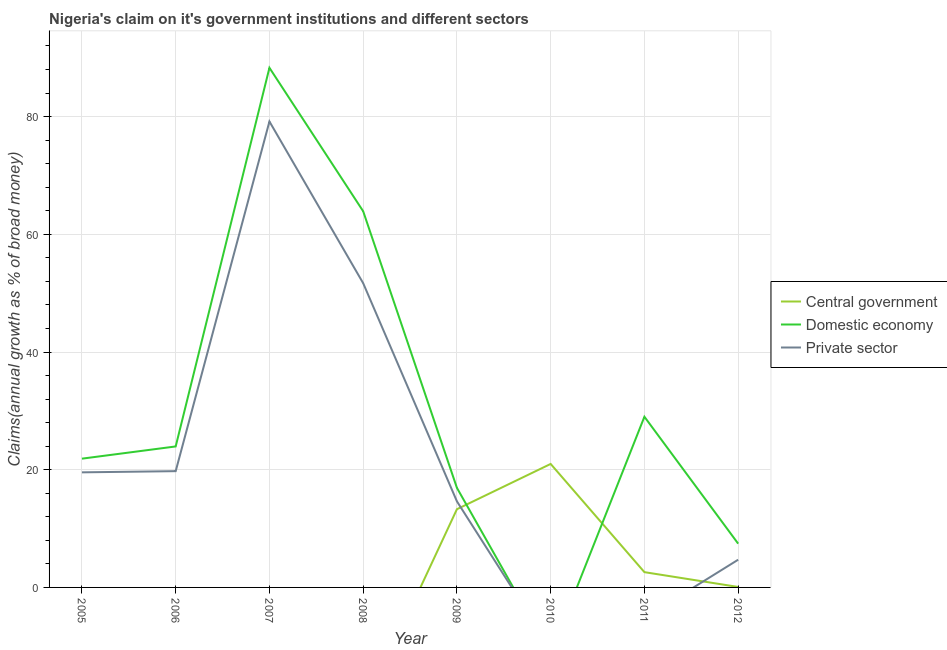Is the number of lines equal to the number of legend labels?
Your answer should be compact. No. What is the percentage of claim on the domestic economy in 2010?
Offer a terse response. 0. Across all years, what is the maximum percentage of claim on the central government?
Provide a short and direct response. 20.98. Across all years, what is the minimum percentage of claim on the central government?
Provide a succinct answer. 0. What is the total percentage of claim on the central government in the graph?
Offer a very short reply. 36.95. What is the difference between the percentage of claim on the private sector in 2006 and that in 2012?
Keep it short and to the point. 15.05. What is the difference between the percentage of claim on the domestic economy in 2005 and the percentage of claim on the central government in 2009?
Your response must be concise. 8.59. What is the average percentage of claim on the private sector per year?
Your answer should be compact. 23.69. In the year 2012, what is the difference between the percentage of claim on the private sector and percentage of claim on the domestic economy?
Provide a short and direct response. -2.73. In how many years, is the percentage of claim on the domestic economy greater than 72 %?
Provide a short and direct response. 1. What is the ratio of the percentage of claim on the domestic economy in 2005 to that in 2011?
Ensure brevity in your answer.  0.75. Is the difference between the percentage of claim on the private sector in 2005 and 2012 greater than the difference between the percentage of claim on the domestic economy in 2005 and 2012?
Keep it short and to the point. Yes. What is the difference between the highest and the second highest percentage of claim on the private sector?
Make the answer very short. 27.48. What is the difference between the highest and the lowest percentage of claim on the private sector?
Keep it short and to the point. 79.17. Is it the case that in every year, the sum of the percentage of claim on the central government and percentage of claim on the domestic economy is greater than the percentage of claim on the private sector?
Provide a succinct answer. Yes. What is the difference between two consecutive major ticks on the Y-axis?
Offer a terse response. 20. Are the values on the major ticks of Y-axis written in scientific E-notation?
Keep it short and to the point. No. Does the graph contain any zero values?
Ensure brevity in your answer.  Yes. Does the graph contain grids?
Keep it short and to the point. Yes. How many legend labels are there?
Provide a short and direct response. 3. What is the title of the graph?
Offer a very short reply. Nigeria's claim on it's government institutions and different sectors. Does "Hydroelectric sources" appear as one of the legend labels in the graph?
Your response must be concise. No. What is the label or title of the X-axis?
Offer a terse response. Year. What is the label or title of the Y-axis?
Your response must be concise. Claims(annual growth as % of broad money). What is the Claims(annual growth as % of broad money) of Domestic economy in 2005?
Your response must be concise. 21.88. What is the Claims(annual growth as % of broad money) of Private sector in 2005?
Make the answer very short. 19.56. What is the Claims(annual growth as % of broad money) in Domestic economy in 2006?
Your answer should be compact. 23.95. What is the Claims(annual growth as % of broad money) of Private sector in 2006?
Provide a short and direct response. 19.76. What is the Claims(annual growth as % of broad money) in Domestic economy in 2007?
Keep it short and to the point. 88.3. What is the Claims(annual growth as % of broad money) in Private sector in 2007?
Your answer should be compact. 79.17. What is the Claims(annual growth as % of broad money) in Domestic economy in 2008?
Make the answer very short. 63.92. What is the Claims(annual growth as % of broad money) in Private sector in 2008?
Your response must be concise. 51.69. What is the Claims(annual growth as % of broad money) of Central government in 2009?
Offer a very short reply. 13.29. What is the Claims(annual growth as % of broad money) of Domestic economy in 2009?
Offer a terse response. 16.92. What is the Claims(annual growth as % of broad money) in Private sector in 2009?
Provide a succinct answer. 14.63. What is the Claims(annual growth as % of broad money) of Central government in 2010?
Make the answer very short. 20.98. What is the Claims(annual growth as % of broad money) of Domestic economy in 2010?
Your response must be concise. 0. What is the Claims(annual growth as % of broad money) in Central government in 2011?
Offer a very short reply. 2.6. What is the Claims(annual growth as % of broad money) in Domestic economy in 2011?
Ensure brevity in your answer.  29. What is the Claims(annual growth as % of broad money) in Central government in 2012?
Offer a very short reply. 0.08. What is the Claims(annual growth as % of broad money) in Domestic economy in 2012?
Keep it short and to the point. 7.44. What is the Claims(annual growth as % of broad money) of Private sector in 2012?
Offer a very short reply. 4.71. Across all years, what is the maximum Claims(annual growth as % of broad money) in Central government?
Offer a terse response. 20.98. Across all years, what is the maximum Claims(annual growth as % of broad money) in Domestic economy?
Your answer should be compact. 88.3. Across all years, what is the maximum Claims(annual growth as % of broad money) in Private sector?
Your answer should be compact. 79.17. Across all years, what is the minimum Claims(annual growth as % of broad money) in Private sector?
Your answer should be very brief. 0. What is the total Claims(annual growth as % of broad money) in Central government in the graph?
Provide a succinct answer. 36.95. What is the total Claims(annual growth as % of broad money) of Domestic economy in the graph?
Keep it short and to the point. 251.41. What is the total Claims(annual growth as % of broad money) in Private sector in the graph?
Your answer should be compact. 189.52. What is the difference between the Claims(annual growth as % of broad money) in Domestic economy in 2005 and that in 2006?
Make the answer very short. -2.07. What is the difference between the Claims(annual growth as % of broad money) of Private sector in 2005 and that in 2006?
Give a very brief answer. -0.2. What is the difference between the Claims(annual growth as % of broad money) in Domestic economy in 2005 and that in 2007?
Provide a short and direct response. -66.42. What is the difference between the Claims(annual growth as % of broad money) of Private sector in 2005 and that in 2007?
Make the answer very short. -59.62. What is the difference between the Claims(annual growth as % of broad money) of Domestic economy in 2005 and that in 2008?
Provide a short and direct response. -42.04. What is the difference between the Claims(annual growth as % of broad money) of Private sector in 2005 and that in 2008?
Your answer should be very brief. -32.14. What is the difference between the Claims(annual growth as % of broad money) in Domestic economy in 2005 and that in 2009?
Your answer should be very brief. 4.96. What is the difference between the Claims(annual growth as % of broad money) of Private sector in 2005 and that in 2009?
Offer a very short reply. 4.93. What is the difference between the Claims(annual growth as % of broad money) of Domestic economy in 2005 and that in 2011?
Your response must be concise. -7.12. What is the difference between the Claims(annual growth as % of broad money) of Domestic economy in 2005 and that in 2012?
Provide a succinct answer. 14.44. What is the difference between the Claims(annual growth as % of broad money) in Private sector in 2005 and that in 2012?
Ensure brevity in your answer.  14.85. What is the difference between the Claims(annual growth as % of broad money) of Domestic economy in 2006 and that in 2007?
Your answer should be very brief. -64.34. What is the difference between the Claims(annual growth as % of broad money) in Private sector in 2006 and that in 2007?
Offer a very short reply. -59.42. What is the difference between the Claims(annual growth as % of broad money) in Domestic economy in 2006 and that in 2008?
Offer a very short reply. -39.96. What is the difference between the Claims(annual growth as % of broad money) of Private sector in 2006 and that in 2008?
Provide a succinct answer. -31.94. What is the difference between the Claims(annual growth as % of broad money) in Domestic economy in 2006 and that in 2009?
Keep it short and to the point. 7.03. What is the difference between the Claims(annual growth as % of broad money) of Private sector in 2006 and that in 2009?
Offer a very short reply. 5.13. What is the difference between the Claims(annual growth as % of broad money) in Domestic economy in 2006 and that in 2011?
Offer a very short reply. -5.05. What is the difference between the Claims(annual growth as % of broad money) of Domestic economy in 2006 and that in 2012?
Provide a short and direct response. 16.52. What is the difference between the Claims(annual growth as % of broad money) in Private sector in 2006 and that in 2012?
Keep it short and to the point. 15.05. What is the difference between the Claims(annual growth as % of broad money) of Domestic economy in 2007 and that in 2008?
Give a very brief answer. 24.38. What is the difference between the Claims(annual growth as % of broad money) of Private sector in 2007 and that in 2008?
Your answer should be compact. 27.48. What is the difference between the Claims(annual growth as % of broad money) of Domestic economy in 2007 and that in 2009?
Your response must be concise. 71.38. What is the difference between the Claims(annual growth as % of broad money) in Private sector in 2007 and that in 2009?
Your answer should be very brief. 64.55. What is the difference between the Claims(annual growth as % of broad money) of Domestic economy in 2007 and that in 2011?
Your answer should be compact. 59.3. What is the difference between the Claims(annual growth as % of broad money) of Domestic economy in 2007 and that in 2012?
Provide a succinct answer. 80.86. What is the difference between the Claims(annual growth as % of broad money) in Private sector in 2007 and that in 2012?
Your response must be concise. 74.47. What is the difference between the Claims(annual growth as % of broad money) in Domestic economy in 2008 and that in 2009?
Offer a terse response. 47. What is the difference between the Claims(annual growth as % of broad money) in Private sector in 2008 and that in 2009?
Keep it short and to the point. 37.07. What is the difference between the Claims(annual growth as % of broad money) in Domestic economy in 2008 and that in 2011?
Ensure brevity in your answer.  34.92. What is the difference between the Claims(annual growth as % of broad money) in Domestic economy in 2008 and that in 2012?
Your answer should be compact. 56.48. What is the difference between the Claims(annual growth as % of broad money) in Private sector in 2008 and that in 2012?
Make the answer very short. 46.99. What is the difference between the Claims(annual growth as % of broad money) in Central government in 2009 and that in 2010?
Your response must be concise. -7.69. What is the difference between the Claims(annual growth as % of broad money) in Central government in 2009 and that in 2011?
Give a very brief answer. 10.7. What is the difference between the Claims(annual growth as % of broad money) in Domestic economy in 2009 and that in 2011?
Your answer should be very brief. -12.08. What is the difference between the Claims(annual growth as % of broad money) in Central government in 2009 and that in 2012?
Keep it short and to the point. 13.21. What is the difference between the Claims(annual growth as % of broad money) in Domestic economy in 2009 and that in 2012?
Ensure brevity in your answer.  9.48. What is the difference between the Claims(annual growth as % of broad money) of Private sector in 2009 and that in 2012?
Your response must be concise. 9.92. What is the difference between the Claims(annual growth as % of broad money) in Central government in 2010 and that in 2011?
Your answer should be compact. 18.39. What is the difference between the Claims(annual growth as % of broad money) of Central government in 2010 and that in 2012?
Give a very brief answer. 20.9. What is the difference between the Claims(annual growth as % of broad money) in Central government in 2011 and that in 2012?
Offer a terse response. 2.52. What is the difference between the Claims(annual growth as % of broad money) of Domestic economy in 2011 and that in 2012?
Your response must be concise. 21.57. What is the difference between the Claims(annual growth as % of broad money) of Domestic economy in 2005 and the Claims(annual growth as % of broad money) of Private sector in 2006?
Your response must be concise. 2.12. What is the difference between the Claims(annual growth as % of broad money) of Domestic economy in 2005 and the Claims(annual growth as % of broad money) of Private sector in 2007?
Keep it short and to the point. -57.29. What is the difference between the Claims(annual growth as % of broad money) in Domestic economy in 2005 and the Claims(annual growth as % of broad money) in Private sector in 2008?
Your response must be concise. -29.81. What is the difference between the Claims(annual growth as % of broad money) of Domestic economy in 2005 and the Claims(annual growth as % of broad money) of Private sector in 2009?
Provide a succinct answer. 7.25. What is the difference between the Claims(annual growth as % of broad money) of Domestic economy in 2005 and the Claims(annual growth as % of broad money) of Private sector in 2012?
Make the answer very short. 17.17. What is the difference between the Claims(annual growth as % of broad money) of Domestic economy in 2006 and the Claims(annual growth as % of broad money) of Private sector in 2007?
Give a very brief answer. -55.22. What is the difference between the Claims(annual growth as % of broad money) of Domestic economy in 2006 and the Claims(annual growth as % of broad money) of Private sector in 2008?
Give a very brief answer. -27.74. What is the difference between the Claims(annual growth as % of broad money) of Domestic economy in 2006 and the Claims(annual growth as % of broad money) of Private sector in 2009?
Give a very brief answer. 9.33. What is the difference between the Claims(annual growth as % of broad money) of Domestic economy in 2006 and the Claims(annual growth as % of broad money) of Private sector in 2012?
Ensure brevity in your answer.  19.25. What is the difference between the Claims(annual growth as % of broad money) of Domestic economy in 2007 and the Claims(annual growth as % of broad money) of Private sector in 2008?
Provide a succinct answer. 36.6. What is the difference between the Claims(annual growth as % of broad money) of Domestic economy in 2007 and the Claims(annual growth as % of broad money) of Private sector in 2009?
Provide a succinct answer. 73.67. What is the difference between the Claims(annual growth as % of broad money) of Domestic economy in 2007 and the Claims(annual growth as % of broad money) of Private sector in 2012?
Make the answer very short. 83.59. What is the difference between the Claims(annual growth as % of broad money) of Domestic economy in 2008 and the Claims(annual growth as % of broad money) of Private sector in 2009?
Your answer should be compact. 49.29. What is the difference between the Claims(annual growth as % of broad money) in Domestic economy in 2008 and the Claims(annual growth as % of broad money) in Private sector in 2012?
Your response must be concise. 59.21. What is the difference between the Claims(annual growth as % of broad money) of Central government in 2009 and the Claims(annual growth as % of broad money) of Domestic economy in 2011?
Offer a very short reply. -15.71. What is the difference between the Claims(annual growth as % of broad money) in Central government in 2009 and the Claims(annual growth as % of broad money) in Domestic economy in 2012?
Make the answer very short. 5.85. What is the difference between the Claims(annual growth as % of broad money) in Central government in 2009 and the Claims(annual growth as % of broad money) in Private sector in 2012?
Your response must be concise. 8.58. What is the difference between the Claims(annual growth as % of broad money) of Domestic economy in 2009 and the Claims(annual growth as % of broad money) of Private sector in 2012?
Your response must be concise. 12.21. What is the difference between the Claims(annual growth as % of broad money) in Central government in 2010 and the Claims(annual growth as % of broad money) in Domestic economy in 2011?
Provide a short and direct response. -8.02. What is the difference between the Claims(annual growth as % of broad money) of Central government in 2010 and the Claims(annual growth as % of broad money) of Domestic economy in 2012?
Provide a short and direct response. 13.55. What is the difference between the Claims(annual growth as % of broad money) of Central government in 2010 and the Claims(annual growth as % of broad money) of Private sector in 2012?
Make the answer very short. 16.28. What is the difference between the Claims(annual growth as % of broad money) of Central government in 2011 and the Claims(annual growth as % of broad money) of Domestic economy in 2012?
Provide a short and direct response. -4.84. What is the difference between the Claims(annual growth as % of broad money) of Central government in 2011 and the Claims(annual growth as % of broad money) of Private sector in 2012?
Provide a short and direct response. -2.11. What is the difference between the Claims(annual growth as % of broad money) in Domestic economy in 2011 and the Claims(annual growth as % of broad money) in Private sector in 2012?
Your answer should be very brief. 24.29. What is the average Claims(annual growth as % of broad money) of Central government per year?
Offer a terse response. 4.62. What is the average Claims(annual growth as % of broad money) of Domestic economy per year?
Provide a succinct answer. 31.43. What is the average Claims(annual growth as % of broad money) in Private sector per year?
Your answer should be very brief. 23.69. In the year 2005, what is the difference between the Claims(annual growth as % of broad money) of Domestic economy and Claims(annual growth as % of broad money) of Private sector?
Offer a terse response. 2.32. In the year 2006, what is the difference between the Claims(annual growth as % of broad money) in Domestic economy and Claims(annual growth as % of broad money) in Private sector?
Provide a succinct answer. 4.2. In the year 2007, what is the difference between the Claims(annual growth as % of broad money) in Domestic economy and Claims(annual growth as % of broad money) in Private sector?
Provide a short and direct response. 9.12. In the year 2008, what is the difference between the Claims(annual growth as % of broad money) of Domestic economy and Claims(annual growth as % of broad money) of Private sector?
Ensure brevity in your answer.  12.22. In the year 2009, what is the difference between the Claims(annual growth as % of broad money) in Central government and Claims(annual growth as % of broad money) in Domestic economy?
Provide a short and direct response. -3.63. In the year 2009, what is the difference between the Claims(annual growth as % of broad money) in Central government and Claims(annual growth as % of broad money) in Private sector?
Provide a succinct answer. -1.33. In the year 2009, what is the difference between the Claims(annual growth as % of broad money) in Domestic economy and Claims(annual growth as % of broad money) in Private sector?
Provide a succinct answer. 2.29. In the year 2011, what is the difference between the Claims(annual growth as % of broad money) in Central government and Claims(annual growth as % of broad money) in Domestic economy?
Provide a short and direct response. -26.41. In the year 2012, what is the difference between the Claims(annual growth as % of broad money) in Central government and Claims(annual growth as % of broad money) in Domestic economy?
Your answer should be compact. -7.36. In the year 2012, what is the difference between the Claims(annual growth as % of broad money) of Central government and Claims(annual growth as % of broad money) of Private sector?
Provide a succinct answer. -4.63. In the year 2012, what is the difference between the Claims(annual growth as % of broad money) of Domestic economy and Claims(annual growth as % of broad money) of Private sector?
Offer a very short reply. 2.73. What is the ratio of the Claims(annual growth as % of broad money) in Domestic economy in 2005 to that in 2006?
Provide a succinct answer. 0.91. What is the ratio of the Claims(annual growth as % of broad money) of Private sector in 2005 to that in 2006?
Keep it short and to the point. 0.99. What is the ratio of the Claims(annual growth as % of broad money) of Domestic economy in 2005 to that in 2007?
Your answer should be compact. 0.25. What is the ratio of the Claims(annual growth as % of broad money) of Private sector in 2005 to that in 2007?
Provide a succinct answer. 0.25. What is the ratio of the Claims(annual growth as % of broad money) in Domestic economy in 2005 to that in 2008?
Make the answer very short. 0.34. What is the ratio of the Claims(annual growth as % of broad money) in Private sector in 2005 to that in 2008?
Your answer should be compact. 0.38. What is the ratio of the Claims(annual growth as % of broad money) of Domestic economy in 2005 to that in 2009?
Provide a succinct answer. 1.29. What is the ratio of the Claims(annual growth as % of broad money) of Private sector in 2005 to that in 2009?
Offer a terse response. 1.34. What is the ratio of the Claims(annual growth as % of broad money) of Domestic economy in 2005 to that in 2011?
Offer a terse response. 0.75. What is the ratio of the Claims(annual growth as % of broad money) in Domestic economy in 2005 to that in 2012?
Offer a very short reply. 2.94. What is the ratio of the Claims(annual growth as % of broad money) of Private sector in 2005 to that in 2012?
Keep it short and to the point. 4.15. What is the ratio of the Claims(annual growth as % of broad money) of Domestic economy in 2006 to that in 2007?
Give a very brief answer. 0.27. What is the ratio of the Claims(annual growth as % of broad money) of Private sector in 2006 to that in 2007?
Keep it short and to the point. 0.25. What is the ratio of the Claims(annual growth as % of broad money) in Domestic economy in 2006 to that in 2008?
Your answer should be very brief. 0.37. What is the ratio of the Claims(annual growth as % of broad money) of Private sector in 2006 to that in 2008?
Your answer should be compact. 0.38. What is the ratio of the Claims(annual growth as % of broad money) in Domestic economy in 2006 to that in 2009?
Offer a very short reply. 1.42. What is the ratio of the Claims(annual growth as % of broad money) in Private sector in 2006 to that in 2009?
Provide a short and direct response. 1.35. What is the ratio of the Claims(annual growth as % of broad money) in Domestic economy in 2006 to that in 2011?
Keep it short and to the point. 0.83. What is the ratio of the Claims(annual growth as % of broad money) in Domestic economy in 2006 to that in 2012?
Offer a terse response. 3.22. What is the ratio of the Claims(annual growth as % of broad money) of Private sector in 2006 to that in 2012?
Your answer should be compact. 4.2. What is the ratio of the Claims(annual growth as % of broad money) of Domestic economy in 2007 to that in 2008?
Keep it short and to the point. 1.38. What is the ratio of the Claims(annual growth as % of broad money) of Private sector in 2007 to that in 2008?
Your answer should be very brief. 1.53. What is the ratio of the Claims(annual growth as % of broad money) of Domestic economy in 2007 to that in 2009?
Give a very brief answer. 5.22. What is the ratio of the Claims(annual growth as % of broad money) in Private sector in 2007 to that in 2009?
Offer a terse response. 5.41. What is the ratio of the Claims(annual growth as % of broad money) in Domestic economy in 2007 to that in 2011?
Provide a succinct answer. 3.04. What is the ratio of the Claims(annual growth as % of broad money) of Domestic economy in 2007 to that in 2012?
Offer a terse response. 11.87. What is the ratio of the Claims(annual growth as % of broad money) of Private sector in 2007 to that in 2012?
Offer a very short reply. 16.82. What is the ratio of the Claims(annual growth as % of broad money) in Domestic economy in 2008 to that in 2009?
Ensure brevity in your answer.  3.78. What is the ratio of the Claims(annual growth as % of broad money) of Private sector in 2008 to that in 2009?
Provide a succinct answer. 3.53. What is the ratio of the Claims(annual growth as % of broad money) of Domestic economy in 2008 to that in 2011?
Provide a succinct answer. 2.2. What is the ratio of the Claims(annual growth as % of broad money) in Domestic economy in 2008 to that in 2012?
Your response must be concise. 8.59. What is the ratio of the Claims(annual growth as % of broad money) in Private sector in 2008 to that in 2012?
Provide a succinct answer. 10.98. What is the ratio of the Claims(annual growth as % of broad money) of Central government in 2009 to that in 2010?
Make the answer very short. 0.63. What is the ratio of the Claims(annual growth as % of broad money) of Central government in 2009 to that in 2011?
Your answer should be very brief. 5.12. What is the ratio of the Claims(annual growth as % of broad money) in Domestic economy in 2009 to that in 2011?
Your response must be concise. 0.58. What is the ratio of the Claims(annual growth as % of broad money) in Central government in 2009 to that in 2012?
Offer a very short reply. 166.89. What is the ratio of the Claims(annual growth as % of broad money) of Domestic economy in 2009 to that in 2012?
Offer a terse response. 2.28. What is the ratio of the Claims(annual growth as % of broad money) of Private sector in 2009 to that in 2012?
Provide a short and direct response. 3.11. What is the ratio of the Claims(annual growth as % of broad money) of Central government in 2010 to that in 2011?
Your answer should be compact. 8.08. What is the ratio of the Claims(annual growth as % of broad money) in Central government in 2010 to that in 2012?
Ensure brevity in your answer.  263.48. What is the ratio of the Claims(annual growth as % of broad money) in Central government in 2011 to that in 2012?
Your answer should be very brief. 32.59. What is the ratio of the Claims(annual growth as % of broad money) in Domestic economy in 2011 to that in 2012?
Offer a very short reply. 3.9. What is the difference between the highest and the second highest Claims(annual growth as % of broad money) in Central government?
Provide a succinct answer. 7.69. What is the difference between the highest and the second highest Claims(annual growth as % of broad money) in Domestic economy?
Offer a terse response. 24.38. What is the difference between the highest and the second highest Claims(annual growth as % of broad money) of Private sector?
Offer a terse response. 27.48. What is the difference between the highest and the lowest Claims(annual growth as % of broad money) in Central government?
Your response must be concise. 20.98. What is the difference between the highest and the lowest Claims(annual growth as % of broad money) of Domestic economy?
Make the answer very short. 88.3. What is the difference between the highest and the lowest Claims(annual growth as % of broad money) in Private sector?
Provide a succinct answer. 79.17. 